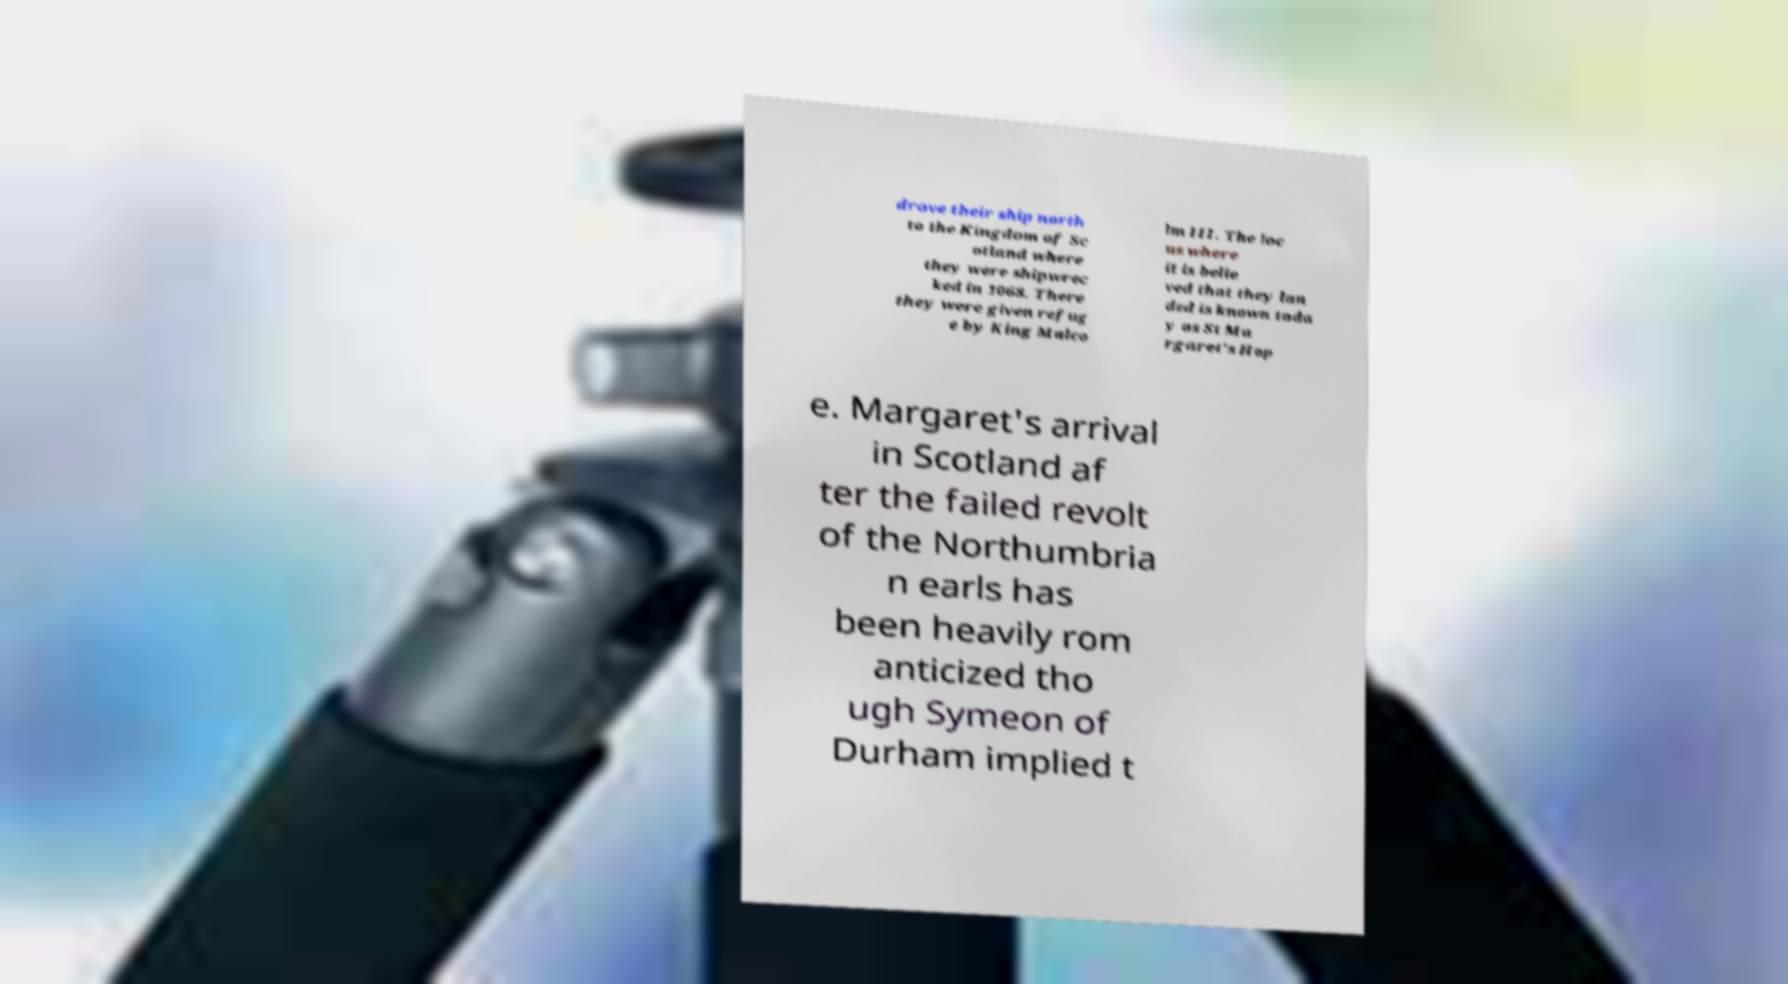There's text embedded in this image that I need extracted. Can you transcribe it verbatim? drove their ship north to the Kingdom of Sc otland where they were shipwrec ked in 1068. There they were given refug e by King Malco lm III. The loc us where it is belie ved that they lan ded is known toda y as St Ma rgaret's Hop e. Margaret's arrival in Scotland af ter the failed revolt of the Northumbria n earls has been heavily rom anticized tho ugh Symeon of Durham implied t 